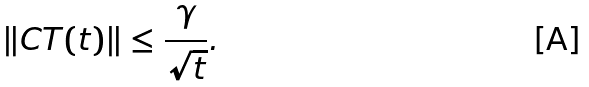<formula> <loc_0><loc_0><loc_500><loc_500>\| C T ( t ) \| \leq \frac { \gamma } { \sqrt { t } } .</formula> 